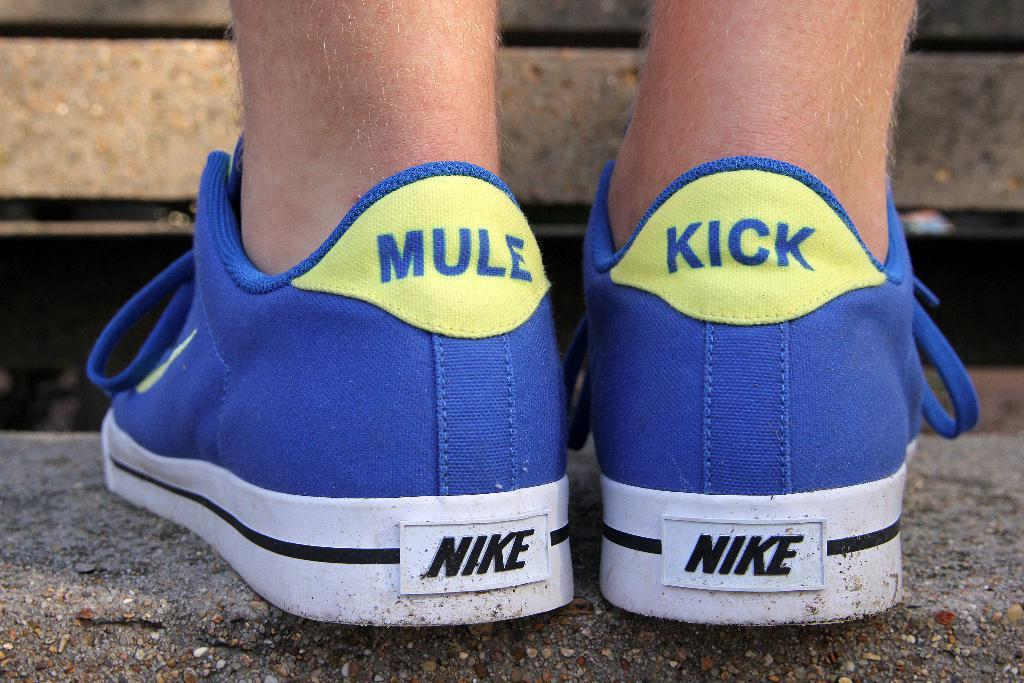Provide a one-sentence caption for the provided image. A pair of blue Nike sneakers have been modified to display the word MULE on one and KICK on the other. 